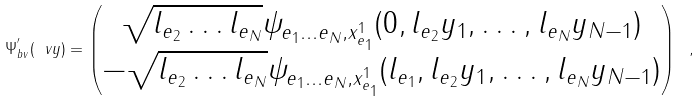<formula> <loc_0><loc_0><loc_500><loc_500>\Psi ^ { ^ { \prime } } _ { b v } ( \ v y ) = \begin{pmatrix} \sqrt { l _ { e _ { 2 } } \dots l _ { e _ { N } } } \psi _ { e _ { 1 } \dots e _ { N } , x ^ { 1 } _ { e _ { 1 } } } ( 0 , l _ { e _ { 2 } } y _ { 1 } , \dots , l _ { e _ { N } } y _ { N - 1 } ) \\ - \sqrt { l _ { e _ { 2 } } \dots l _ { e _ { N } } } \psi _ { e _ { 1 } \dots e _ { N } , x ^ { 1 } _ { e _ { 1 } } } ( l _ { e _ { 1 } } , l _ { e _ { 2 } } y _ { 1 } , \dots , l _ { e _ { N } } y _ { N - 1 } ) \end{pmatrix} \ ,</formula> 